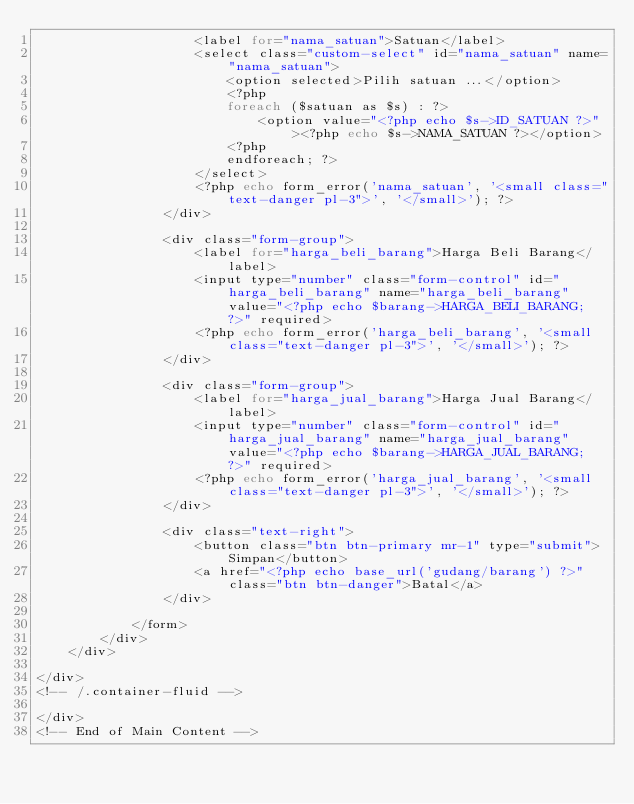Convert code to text. <code><loc_0><loc_0><loc_500><loc_500><_PHP_>                    <label for="nama_satuan">Satuan</label>
                    <select class="custom-select" id="nama_satuan" name="nama_satuan">
                        <option selected>Pilih satuan ...</option>
                        <?php
                        foreach ($satuan as $s) : ?>
                            <option value="<?php echo $s->ID_SATUAN ?>"><?php echo $s->NAMA_SATUAN ?></option>
                        <?php
                        endforeach; ?>
                    </select>
                    <?php echo form_error('nama_satuan', '<small class="text-danger pl-3">', '</small>'); ?>
                </div>

                <div class="form-group">
                    <label for="harga_beli_barang">Harga Beli Barang</label>
                    <input type="number" class="form-control" id="harga_beli_barang" name="harga_beli_barang" value="<?php echo $barang->HARGA_BELI_BARANG; ?>" required>
                    <?php echo form_error('harga_beli_barang', '<small class="text-danger pl-3">', '</small>'); ?>
                </div>

                <div class="form-group">
                    <label for="harga_jual_barang">Harga Jual Barang</label>
                    <input type="number" class="form-control" id="harga_jual_barang" name="harga_jual_barang" value="<?php echo $barang->HARGA_JUAL_BARANG; ?>" required>
                    <?php echo form_error('harga_jual_barang', '<small class="text-danger pl-3">', '</small>'); ?>
                </div>

                <div class="text-right">
                    <button class="btn btn-primary mr-1" type="submit">Simpan</button>
                    <a href="<?php echo base_url('gudang/barang') ?>" class="btn btn-danger">Batal</a>
                </div>

            </form>
        </div>
    </div>

</div>
<!-- /.container-fluid -->

</div>
<!-- End of Main Content --></code> 